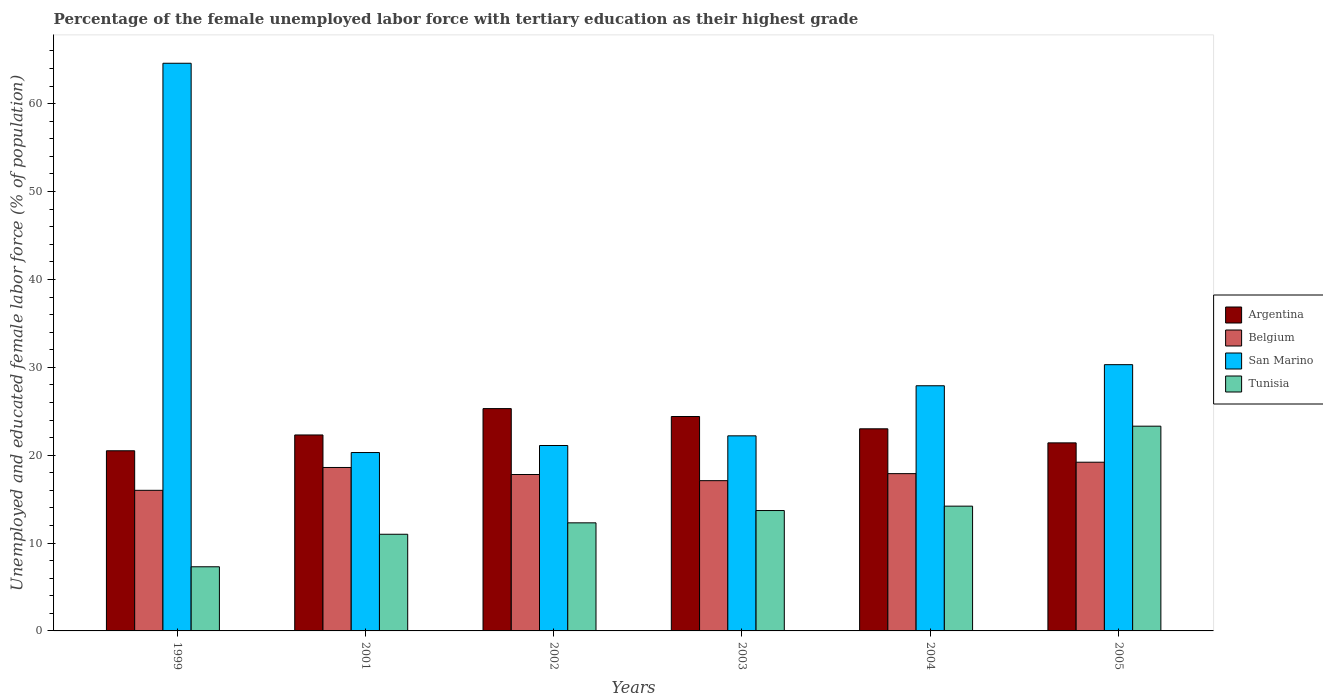Are the number of bars per tick equal to the number of legend labels?
Your answer should be very brief. Yes. Are the number of bars on each tick of the X-axis equal?
Make the answer very short. Yes. How many bars are there on the 2nd tick from the left?
Your response must be concise. 4. What is the label of the 2nd group of bars from the left?
Your response must be concise. 2001. In how many cases, is the number of bars for a given year not equal to the number of legend labels?
Keep it short and to the point. 0. What is the percentage of the unemployed female labor force with tertiary education in Belgium in 2001?
Keep it short and to the point. 18.6. Across all years, what is the maximum percentage of the unemployed female labor force with tertiary education in San Marino?
Your answer should be very brief. 64.6. Across all years, what is the minimum percentage of the unemployed female labor force with tertiary education in Argentina?
Give a very brief answer. 20.5. In which year was the percentage of the unemployed female labor force with tertiary education in Tunisia maximum?
Offer a terse response. 2005. In which year was the percentage of the unemployed female labor force with tertiary education in Belgium minimum?
Provide a short and direct response. 1999. What is the total percentage of the unemployed female labor force with tertiary education in Argentina in the graph?
Provide a succinct answer. 136.9. What is the difference between the percentage of the unemployed female labor force with tertiary education in San Marino in 1999 and that in 2005?
Provide a short and direct response. 34.3. What is the difference between the percentage of the unemployed female labor force with tertiary education in Tunisia in 2003 and the percentage of the unemployed female labor force with tertiary education in Belgium in 2005?
Your answer should be compact. -5.5. What is the average percentage of the unemployed female labor force with tertiary education in Argentina per year?
Your answer should be very brief. 22.82. In the year 2001, what is the difference between the percentage of the unemployed female labor force with tertiary education in San Marino and percentage of the unemployed female labor force with tertiary education in Belgium?
Ensure brevity in your answer.  1.7. In how many years, is the percentage of the unemployed female labor force with tertiary education in Belgium greater than 16 %?
Give a very brief answer. 5. What is the ratio of the percentage of the unemployed female labor force with tertiary education in Belgium in 2003 to that in 2004?
Keep it short and to the point. 0.96. What is the difference between the highest and the second highest percentage of the unemployed female labor force with tertiary education in Tunisia?
Your answer should be compact. 9.1. What is the difference between the highest and the lowest percentage of the unemployed female labor force with tertiary education in Belgium?
Your answer should be very brief. 3.2. What does the 3rd bar from the left in 2001 represents?
Offer a terse response. San Marino. What does the 3rd bar from the right in 2005 represents?
Provide a short and direct response. Belgium. Is it the case that in every year, the sum of the percentage of the unemployed female labor force with tertiary education in Argentina and percentage of the unemployed female labor force with tertiary education in Tunisia is greater than the percentage of the unemployed female labor force with tertiary education in San Marino?
Your answer should be very brief. No. How many bars are there?
Offer a very short reply. 24. Are all the bars in the graph horizontal?
Provide a short and direct response. No. How many years are there in the graph?
Offer a very short reply. 6. What is the difference between two consecutive major ticks on the Y-axis?
Your answer should be compact. 10. Are the values on the major ticks of Y-axis written in scientific E-notation?
Your answer should be compact. No. Does the graph contain any zero values?
Provide a short and direct response. No. What is the title of the graph?
Your response must be concise. Percentage of the female unemployed labor force with tertiary education as their highest grade. Does "Mali" appear as one of the legend labels in the graph?
Give a very brief answer. No. What is the label or title of the Y-axis?
Your answer should be very brief. Unemployed and educated female labor force (% of population). What is the Unemployed and educated female labor force (% of population) of Belgium in 1999?
Your answer should be compact. 16. What is the Unemployed and educated female labor force (% of population) in San Marino in 1999?
Make the answer very short. 64.6. What is the Unemployed and educated female labor force (% of population) of Tunisia in 1999?
Provide a succinct answer. 7.3. What is the Unemployed and educated female labor force (% of population) in Argentina in 2001?
Provide a succinct answer. 22.3. What is the Unemployed and educated female labor force (% of population) of Belgium in 2001?
Make the answer very short. 18.6. What is the Unemployed and educated female labor force (% of population) in San Marino in 2001?
Keep it short and to the point. 20.3. What is the Unemployed and educated female labor force (% of population) of Tunisia in 2001?
Provide a succinct answer. 11. What is the Unemployed and educated female labor force (% of population) in Argentina in 2002?
Ensure brevity in your answer.  25.3. What is the Unemployed and educated female labor force (% of population) in Belgium in 2002?
Offer a terse response. 17.8. What is the Unemployed and educated female labor force (% of population) of San Marino in 2002?
Your response must be concise. 21.1. What is the Unemployed and educated female labor force (% of population) of Tunisia in 2002?
Your response must be concise. 12.3. What is the Unemployed and educated female labor force (% of population) of Argentina in 2003?
Your response must be concise. 24.4. What is the Unemployed and educated female labor force (% of population) in Belgium in 2003?
Ensure brevity in your answer.  17.1. What is the Unemployed and educated female labor force (% of population) in San Marino in 2003?
Provide a short and direct response. 22.2. What is the Unemployed and educated female labor force (% of population) in Tunisia in 2003?
Offer a terse response. 13.7. What is the Unemployed and educated female labor force (% of population) of Belgium in 2004?
Offer a terse response. 17.9. What is the Unemployed and educated female labor force (% of population) of San Marino in 2004?
Ensure brevity in your answer.  27.9. What is the Unemployed and educated female labor force (% of population) in Tunisia in 2004?
Your answer should be very brief. 14.2. What is the Unemployed and educated female labor force (% of population) in Argentina in 2005?
Your response must be concise. 21.4. What is the Unemployed and educated female labor force (% of population) in Belgium in 2005?
Offer a very short reply. 19.2. What is the Unemployed and educated female labor force (% of population) in San Marino in 2005?
Your response must be concise. 30.3. What is the Unemployed and educated female labor force (% of population) in Tunisia in 2005?
Make the answer very short. 23.3. Across all years, what is the maximum Unemployed and educated female labor force (% of population) in Argentina?
Your answer should be compact. 25.3. Across all years, what is the maximum Unemployed and educated female labor force (% of population) of Belgium?
Provide a short and direct response. 19.2. Across all years, what is the maximum Unemployed and educated female labor force (% of population) in San Marino?
Offer a terse response. 64.6. Across all years, what is the maximum Unemployed and educated female labor force (% of population) of Tunisia?
Provide a succinct answer. 23.3. Across all years, what is the minimum Unemployed and educated female labor force (% of population) in San Marino?
Your answer should be very brief. 20.3. Across all years, what is the minimum Unemployed and educated female labor force (% of population) of Tunisia?
Keep it short and to the point. 7.3. What is the total Unemployed and educated female labor force (% of population) of Argentina in the graph?
Give a very brief answer. 136.9. What is the total Unemployed and educated female labor force (% of population) in Belgium in the graph?
Offer a very short reply. 106.6. What is the total Unemployed and educated female labor force (% of population) of San Marino in the graph?
Offer a very short reply. 186.4. What is the total Unemployed and educated female labor force (% of population) in Tunisia in the graph?
Offer a terse response. 81.8. What is the difference between the Unemployed and educated female labor force (% of population) in San Marino in 1999 and that in 2001?
Keep it short and to the point. 44.3. What is the difference between the Unemployed and educated female labor force (% of population) of Tunisia in 1999 and that in 2001?
Your response must be concise. -3.7. What is the difference between the Unemployed and educated female labor force (% of population) of Belgium in 1999 and that in 2002?
Provide a succinct answer. -1.8. What is the difference between the Unemployed and educated female labor force (% of population) of San Marino in 1999 and that in 2002?
Ensure brevity in your answer.  43.5. What is the difference between the Unemployed and educated female labor force (% of population) in Argentina in 1999 and that in 2003?
Provide a short and direct response. -3.9. What is the difference between the Unemployed and educated female labor force (% of population) of Belgium in 1999 and that in 2003?
Offer a terse response. -1.1. What is the difference between the Unemployed and educated female labor force (% of population) of San Marino in 1999 and that in 2003?
Provide a succinct answer. 42.4. What is the difference between the Unemployed and educated female labor force (% of population) in Tunisia in 1999 and that in 2003?
Provide a succinct answer. -6.4. What is the difference between the Unemployed and educated female labor force (% of population) of Argentina in 1999 and that in 2004?
Your answer should be compact. -2.5. What is the difference between the Unemployed and educated female labor force (% of population) of Belgium in 1999 and that in 2004?
Ensure brevity in your answer.  -1.9. What is the difference between the Unemployed and educated female labor force (% of population) of San Marino in 1999 and that in 2004?
Provide a short and direct response. 36.7. What is the difference between the Unemployed and educated female labor force (% of population) in San Marino in 1999 and that in 2005?
Your answer should be compact. 34.3. What is the difference between the Unemployed and educated female labor force (% of population) in Argentina in 2001 and that in 2002?
Your answer should be compact. -3. What is the difference between the Unemployed and educated female labor force (% of population) in Belgium in 2001 and that in 2002?
Provide a succinct answer. 0.8. What is the difference between the Unemployed and educated female labor force (% of population) of Tunisia in 2001 and that in 2002?
Keep it short and to the point. -1.3. What is the difference between the Unemployed and educated female labor force (% of population) in Argentina in 2001 and that in 2003?
Offer a terse response. -2.1. What is the difference between the Unemployed and educated female labor force (% of population) of Belgium in 2001 and that in 2004?
Provide a short and direct response. 0.7. What is the difference between the Unemployed and educated female labor force (% of population) in Tunisia in 2001 and that in 2004?
Ensure brevity in your answer.  -3.2. What is the difference between the Unemployed and educated female labor force (% of population) of San Marino in 2001 and that in 2005?
Offer a very short reply. -10. What is the difference between the Unemployed and educated female labor force (% of population) of Argentina in 2002 and that in 2003?
Offer a terse response. 0.9. What is the difference between the Unemployed and educated female labor force (% of population) of Belgium in 2002 and that in 2003?
Make the answer very short. 0.7. What is the difference between the Unemployed and educated female labor force (% of population) of San Marino in 2002 and that in 2003?
Keep it short and to the point. -1.1. What is the difference between the Unemployed and educated female labor force (% of population) of Belgium in 2002 and that in 2004?
Offer a very short reply. -0.1. What is the difference between the Unemployed and educated female labor force (% of population) of San Marino in 2002 and that in 2004?
Make the answer very short. -6.8. What is the difference between the Unemployed and educated female labor force (% of population) in Tunisia in 2002 and that in 2004?
Make the answer very short. -1.9. What is the difference between the Unemployed and educated female labor force (% of population) of San Marino in 2002 and that in 2005?
Provide a short and direct response. -9.2. What is the difference between the Unemployed and educated female labor force (% of population) of Tunisia in 2002 and that in 2005?
Provide a short and direct response. -11. What is the difference between the Unemployed and educated female labor force (% of population) of Belgium in 2003 and that in 2004?
Make the answer very short. -0.8. What is the difference between the Unemployed and educated female labor force (% of population) of San Marino in 2003 and that in 2004?
Ensure brevity in your answer.  -5.7. What is the difference between the Unemployed and educated female labor force (% of population) of Argentina in 2003 and that in 2005?
Provide a short and direct response. 3. What is the difference between the Unemployed and educated female labor force (% of population) in Belgium in 2003 and that in 2005?
Offer a terse response. -2.1. What is the difference between the Unemployed and educated female labor force (% of population) of San Marino in 2004 and that in 2005?
Provide a succinct answer. -2.4. What is the difference between the Unemployed and educated female labor force (% of population) in Argentina in 1999 and the Unemployed and educated female labor force (% of population) in San Marino in 2001?
Offer a very short reply. 0.2. What is the difference between the Unemployed and educated female labor force (% of population) in Argentina in 1999 and the Unemployed and educated female labor force (% of population) in Tunisia in 2001?
Provide a succinct answer. 9.5. What is the difference between the Unemployed and educated female labor force (% of population) of Belgium in 1999 and the Unemployed and educated female labor force (% of population) of San Marino in 2001?
Provide a short and direct response. -4.3. What is the difference between the Unemployed and educated female labor force (% of population) in San Marino in 1999 and the Unemployed and educated female labor force (% of population) in Tunisia in 2001?
Offer a very short reply. 53.6. What is the difference between the Unemployed and educated female labor force (% of population) in Argentina in 1999 and the Unemployed and educated female labor force (% of population) in Belgium in 2002?
Provide a succinct answer. 2.7. What is the difference between the Unemployed and educated female labor force (% of population) in Argentina in 1999 and the Unemployed and educated female labor force (% of population) in San Marino in 2002?
Offer a terse response. -0.6. What is the difference between the Unemployed and educated female labor force (% of population) of Argentina in 1999 and the Unemployed and educated female labor force (% of population) of Tunisia in 2002?
Your answer should be very brief. 8.2. What is the difference between the Unemployed and educated female labor force (% of population) of Belgium in 1999 and the Unemployed and educated female labor force (% of population) of San Marino in 2002?
Provide a succinct answer. -5.1. What is the difference between the Unemployed and educated female labor force (% of population) of Belgium in 1999 and the Unemployed and educated female labor force (% of population) of Tunisia in 2002?
Make the answer very short. 3.7. What is the difference between the Unemployed and educated female labor force (% of population) of San Marino in 1999 and the Unemployed and educated female labor force (% of population) of Tunisia in 2002?
Your answer should be compact. 52.3. What is the difference between the Unemployed and educated female labor force (% of population) of Argentina in 1999 and the Unemployed and educated female labor force (% of population) of Tunisia in 2003?
Offer a very short reply. 6.8. What is the difference between the Unemployed and educated female labor force (% of population) of Belgium in 1999 and the Unemployed and educated female labor force (% of population) of Tunisia in 2003?
Keep it short and to the point. 2.3. What is the difference between the Unemployed and educated female labor force (% of population) in San Marino in 1999 and the Unemployed and educated female labor force (% of population) in Tunisia in 2003?
Ensure brevity in your answer.  50.9. What is the difference between the Unemployed and educated female labor force (% of population) in Argentina in 1999 and the Unemployed and educated female labor force (% of population) in San Marino in 2004?
Provide a short and direct response. -7.4. What is the difference between the Unemployed and educated female labor force (% of population) of San Marino in 1999 and the Unemployed and educated female labor force (% of population) of Tunisia in 2004?
Ensure brevity in your answer.  50.4. What is the difference between the Unemployed and educated female labor force (% of population) of Argentina in 1999 and the Unemployed and educated female labor force (% of population) of Belgium in 2005?
Keep it short and to the point. 1.3. What is the difference between the Unemployed and educated female labor force (% of population) in Argentina in 1999 and the Unemployed and educated female labor force (% of population) in San Marino in 2005?
Your response must be concise. -9.8. What is the difference between the Unemployed and educated female labor force (% of population) in Belgium in 1999 and the Unemployed and educated female labor force (% of population) in San Marino in 2005?
Your answer should be compact. -14.3. What is the difference between the Unemployed and educated female labor force (% of population) in Belgium in 1999 and the Unemployed and educated female labor force (% of population) in Tunisia in 2005?
Your answer should be very brief. -7.3. What is the difference between the Unemployed and educated female labor force (% of population) of San Marino in 1999 and the Unemployed and educated female labor force (% of population) of Tunisia in 2005?
Provide a short and direct response. 41.3. What is the difference between the Unemployed and educated female labor force (% of population) of Argentina in 2001 and the Unemployed and educated female labor force (% of population) of San Marino in 2002?
Provide a short and direct response. 1.2. What is the difference between the Unemployed and educated female labor force (% of population) in Belgium in 2001 and the Unemployed and educated female labor force (% of population) in San Marino in 2002?
Your answer should be compact. -2.5. What is the difference between the Unemployed and educated female labor force (% of population) in Argentina in 2001 and the Unemployed and educated female labor force (% of population) in Belgium in 2003?
Keep it short and to the point. 5.2. What is the difference between the Unemployed and educated female labor force (% of population) of Argentina in 2001 and the Unemployed and educated female labor force (% of population) of San Marino in 2003?
Your answer should be very brief. 0.1. What is the difference between the Unemployed and educated female labor force (% of population) of Argentina in 2001 and the Unemployed and educated female labor force (% of population) of Tunisia in 2003?
Your response must be concise. 8.6. What is the difference between the Unemployed and educated female labor force (% of population) of San Marino in 2001 and the Unemployed and educated female labor force (% of population) of Tunisia in 2003?
Offer a very short reply. 6.6. What is the difference between the Unemployed and educated female labor force (% of population) in Argentina in 2001 and the Unemployed and educated female labor force (% of population) in San Marino in 2004?
Give a very brief answer. -5.6. What is the difference between the Unemployed and educated female labor force (% of population) of Argentina in 2001 and the Unemployed and educated female labor force (% of population) of Tunisia in 2004?
Your answer should be very brief. 8.1. What is the difference between the Unemployed and educated female labor force (% of population) of Belgium in 2001 and the Unemployed and educated female labor force (% of population) of Tunisia in 2004?
Your answer should be very brief. 4.4. What is the difference between the Unemployed and educated female labor force (% of population) in San Marino in 2001 and the Unemployed and educated female labor force (% of population) in Tunisia in 2004?
Ensure brevity in your answer.  6.1. What is the difference between the Unemployed and educated female labor force (% of population) of Belgium in 2001 and the Unemployed and educated female labor force (% of population) of San Marino in 2005?
Ensure brevity in your answer.  -11.7. What is the difference between the Unemployed and educated female labor force (% of population) of Belgium in 2001 and the Unemployed and educated female labor force (% of population) of Tunisia in 2005?
Your answer should be compact. -4.7. What is the difference between the Unemployed and educated female labor force (% of population) in Argentina in 2002 and the Unemployed and educated female labor force (% of population) in Belgium in 2003?
Offer a terse response. 8.2. What is the difference between the Unemployed and educated female labor force (% of population) of Argentina in 2002 and the Unemployed and educated female labor force (% of population) of Tunisia in 2003?
Provide a succinct answer. 11.6. What is the difference between the Unemployed and educated female labor force (% of population) in San Marino in 2002 and the Unemployed and educated female labor force (% of population) in Tunisia in 2003?
Your answer should be very brief. 7.4. What is the difference between the Unemployed and educated female labor force (% of population) of Argentina in 2002 and the Unemployed and educated female labor force (% of population) of Belgium in 2004?
Your answer should be very brief. 7.4. What is the difference between the Unemployed and educated female labor force (% of population) of Argentina in 2002 and the Unemployed and educated female labor force (% of population) of Tunisia in 2004?
Your answer should be very brief. 11.1. What is the difference between the Unemployed and educated female labor force (% of population) of Belgium in 2002 and the Unemployed and educated female labor force (% of population) of Tunisia in 2004?
Ensure brevity in your answer.  3.6. What is the difference between the Unemployed and educated female labor force (% of population) of San Marino in 2002 and the Unemployed and educated female labor force (% of population) of Tunisia in 2004?
Keep it short and to the point. 6.9. What is the difference between the Unemployed and educated female labor force (% of population) in Argentina in 2002 and the Unemployed and educated female labor force (% of population) in Belgium in 2005?
Your answer should be very brief. 6.1. What is the difference between the Unemployed and educated female labor force (% of population) in Argentina in 2002 and the Unemployed and educated female labor force (% of population) in Tunisia in 2005?
Give a very brief answer. 2. What is the difference between the Unemployed and educated female labor force (% of population) of Belgium in 2002 and the Unemployed and educated female labor force (% of population) of Tunisia in 2005?
Your response must be concise. -5.5. What is the difference between the Unemployed and educated female labor force (% of population) in San Marino in 2002 and the Unemployed and educated female labor force (% of population) in Tunisia in 2005?
Give a very brief answer. -2.2. What is the difference between the Unemployed and educated female labor force (% of population) of Argentina in 2003 and the Unemployed and educated female labor force (% of population) of San Marino in 2004?
Keep it short and to the point. -3.5. What is the difference between the Unemployed and educated female labor force (% of population) of Argentina in 2003 and the Unemployed and educated female labor force (% of population) of Tunisia in 2004?
Provide a succinct answer. 10.2. What is the difference between the Unemployed and educated female labor force (% of population) of Belgium in 2003 and the Unemployed and educated female labor force (% of population) of San Marino in 2004?
Your answer should be compact. -10.8. What is the difference between the Unemployed and educated female labor force (% of population) in Argentina in 2003 and the Unemployed and educated female labor force (% of population) in Belgium in 2005?
Provide a short and direct response. 5.2. What is the difference between the Unemployed and educated female labor force (% of population) in Belgium in 2003 and the Unemployed and educated female labor force (% of population) in Tunisia in 2005?
Provide a short and direct response. -6.2. What is the difference between the Unemployed and educated female labor force (% of population) in San Marino in 2003 and the Unemployed and educated female labor force (% of population) in Tunisia in 2005?
Keep it short and to the point. -1.1. What is the difference between the Unemployed and educated female labor force (% of population) of Argentina in 2004 and the Unemployed and educated female labor force (% of population) of Tunisia in 2005?
Offer a terse response. -0.3. What is the difference between the Unemployed and educated female labor force (% of population) in Belgium in 2004 and the Unemployed and educated female labor force (% of population) in San Marino in 2005?
Make the answer very short. -12.4. What is the difference between the Unemployed and educated female labor force (% of population) in San Marino in 2004 and the Unemployed and educated female labor force (% of population) in Tunisia in 2005?
Keep it short and to the point. 4.6. What is the average Unemployed and educated female labor force (% of population) of Argentina per year?
Your response must be concise. 22.82. What is the average Unemployed and educated female labor force (% of population) of Belgium per year?
Your answer should be compact. 17.77. What is the average Unemployed and educated female labor force (% of population) in San Marino per year?
Offer a very short reply. 31.07. What is the average Unemployed and educated female labor force (% of population) in Tunisia per year?
Ensure brevity in your answer.  13.63. In the year 1999, what is the difference between the Unemployed and educated female labor force (% of population) of Argentina and Unemployed and educated female labor force (% of population) of Belgium?
Provide a short and direct response. 4.5. In the year 1999, what is the difference between the Unemployed and educated female labor force (% of population) in Argentina and Unemployed and educated female labor force (% of population) in San Marino?
Keep it short and to the point. -44.1. In the year 1999, what is the difference between the Unemployed and educated female labor force (% of population) in Argentina and Unemployed and educated female labor force (% of population) in Tunisia?
Make the answer very short. 13.2. In the year 1999, what is the difference between the Unemployed and educated female labor force (% of population) of Belgium and Unemployed and educated female labor force (% of population) of San Marino?
Provide a short and direct response. -48.6. In the year 1999, what is the difference between the Unemployed and educated female labor force (% of population) of Belgium and Unemployed and educated female labor force (% of population) of Tunisia?
Provide a succinct answer. 8.7. In the year 1999, what is the difference between the Unemployed and educated female labor force (% of population) in San Marino and Unemployed and educated female labor force (% of population) in Tunisia?
Keep it short and to the point. 57.3. In the year 2001, what is the difference between the Unemployed and educated female labor force (% of population) in Argentina and Unemployed and educated female labor force (% of population) in Belgium?
Offer a very short reply. 3.7. In the year 2001, what is the difference between the Unemployed and educated female labor force (% of population) in Argentina and Unemployed and educated female labor force (% of population) in San Marino?
Make the answer very short. 2. In the year 2001, what is the difference between the Unemployed and educated female labor force (% of population) of Argentina and Unemployed and educated female labor force (% of population) of Tunisia?
Keep it short and to the point. 11.3. In the year 2001, what is the difference between the Unemployed and educated female labor force (% of population) in Belgium and Unemployed and educated female labor force (% of population) in San Marino?
Make the answer very short. -1.7. In the year 2001, what is the difference between the Unemployed and educated female labor force (% of population) of San Marino and Unemployed and educated female labor force (% of population) of Tunisia?
Provide a succinct answer. 9.3. In the year 2002, what is the difference between the Unemployed and educated female labor force (% of population) of Argentina and Unemployed and educated female labor force (% of population) of Belgium?
Your answer should be very brief. 7.5. In the year 2002, what is the difference between the Unemployed and educated female labor force (% of population) in Argentina and Unemployed and educated female labor force (% of population) in San Marino?
Offer a terse response. 4.2. In the year 2002, what is the difference between the Unemployed and educated female labor force (% of population) in Argentina and Unemployed and educated female labor force (% of population) in Tunisia?
Your answer should be very brief. 13. In the year 2002, what is the difference between the Unemployed and educated female labor force (% of population) of San Marino and Unemployed and educated female labor force (% of population) of Tunisia?
Provide a short and direct response. 8.8. In the year 2003, what is the difference between the Unemployed and educated female labor force (% of population) of Argentina and Unemployed and educated female labor force (% of population) of Tunisia?
Keep it short and to the point. 10.7. In the year 2003, what is the difference between the Unemployed and educated female labor force (% of population) of Belgium and Unemployed and educated female labor force (% of population) of San Marino?
Offer a terse response. -5.1. In the year 2003, what is the difference between the Unemployed and educated female labor force (% of population) in Belgium and Unemployed and educated female labor force (% of population) in Tunisia?
Ensure brevity in your answer.  3.4. In the year 2003, what is the difference between the Unemployed and educated female labor force (% of population) in San Marino and Unemployed and educated female labor force (% of population) in Tunisia?
Give a very brief answer. 8.5. In the year 2004, what is the difference between the Unemployed and educated female labor force (% of population) of Argentina and Unemployed and educated female labor force (% of population) of Belgium?
Provide a succinct answer. 5.1. In the year 2004, what is the difference between the Unemployed and educated female labor force (% of population) in Belgium and Unemployed and educated female labor force (% of population) in Tunisia?
Your answer should be very brief. 3.7. In the year 2005, what is the difference between the Unemployed and educated female labor force (% of population) of Argentina and Unemployed and educated female labor force (% of population) of Belgium?
Keep it short and to the point. 2.2. In the year 2005, what is the difference between the Unemployed and educated female labor force (% of population) of Argentina and Unemployed and educated female labor force (% of population) of San Marino?
Give a very brief answer. -8.9. In the year 2005, what is the difference between the Unemployed and educated female labor force (% of population) in Belgium and Unemployed and educated female labor force (% of population) in San Marino?
Your answer should be compact. -11.1. In the year 2005, what is the difference between the Unemployed and educated female labor force (% of population) in Belgium and Unemployed and educated female labor force (% of population) in Tunisia?
Ensure brevity in your answer.  -4.1. In the year 2005, what is the difference between the Unemployed and educated female labor force (% of population) of San Marino and Unemployed and educated female labor force (% of population) of Tunisia?
Your answer should be compact. 7. What is the ratio of the Unemployed and educated female labor force (% of population) in Argentina in 1999 to that in 2001?
Give a very brief answer. 0.92. What is the ratio of the Unemployed and educated female labor force (% of population) of Belgium in 1999 to that in 2001?
Your response must be concise. 0.86. What is the ratio of the Unemployed and educated female labor force (% of population) of San Marino in 1999 to that in 2001?
Keep it short and to the point. 3.18. What is the ratio of the Unemployed and educated female labor force (% of population) of Tunisia in 1999 to that in 2001?
Ensure brevity in your answer.  0.66. What is the ratio of the Unemployed and educated female labor force (% of population) in Argentina in 1999 to that in 2002?
Make the answer very short. 0.81. What is the ratio of the Unemployed and educated female labor force (% of population) in Belgium in 1999 to that in 2002?
Give a very brief answer. 0.9. What is the ratio of the Unemployed and educated female labor force (% of population) of San Marino in 1999 to that in 2002?
Keep it short and to the point. 3.06. What is the ratio of the Unemployed and educated female labor force (% of population) in Tunisia in 1999 to that in 2002?
Your response must be concise. 0.59. What is the ratio of the Unemployed and educated female labor force (% of population) of Argentina in 1999 to that in 2003?
Make the answer very short. 0.84. What is the ratio of the Unemployed and educated female labor force (% of population) of Belgium in 1999 to that in 2003?
Keep it short and to the point. 0.94. What is the ratio of the Unemployed and educated female labor force (% of population) in San Marino in 1999 to that in 2003?
Make the answer very short. 2.91. What is the ratio of the Unemployed and educated female labor force (% of population) of Tunisia in 1999 to that in 2003?
Offer a terse response. 0.53. What is the ratio of the Unemployed and educated female labor force (% of population) in Argentina in 1999 to that in 2004?
Give a very brief answer. 0.89. What is the ratio of the Unemployed and educated female labor force (% of population) in Belgium in 1999 to that in 2004?
Provide a short and direct response. 0.89. What is the ratio of the Unemployed and educated female labor force (% of population) of San Marino in 1999 to that in 2004?
Your response must be concise. 2.32. What is the ratio of the Unemployed and educated female labor force (% of population) of Tunisia in 1999 to that in 2004?
Your answer should be very brief. 0.51. What is the ratio of the Unemployed and educated female labor force (% of population) in Argentina in 1999 to that in 2005?
Your answer should be compact. 0.96. What is the ratio of the Unemployed and educated female labor force (% of population) of Belgium in 1999 to that in 2005?
Your answer should be compact. 0.83. What is the ratio of the Unemployed and educated female labor force (% of population) of San Marino in 1999 to that in 2005?
Your response must be concise. 2.13. What is the ratio of the Unemployed and educated female labor force (% of population) in Tunisia in 1999 to that in 2005?
Keep it short and to the point. 0.31. What is the ratio of the Unemployed and educated female labor force (% of population) in Argentina in 2001 to that in 2002?
Provide a succinct answer. 0.88. What is the ratio of the Unemployed and educated female labor force (% of population) in Belgium in 2001 to that in 2002?
Your answer should be compact. 1.04. What is the ratio of the Unemployed and educated female labor force (% of population) in San Marino in 2001 to that in 2002?
Keep it short and to the point. 0.96. What is the ratio of the Unemployed and educated female labor force (% of population) of Tunisia in 2001 to that in 2002?
Make the answer very short. 0.89. What is the ratio of the Unemployed and educated female labor force (% of population) of Argentina in 2001 to that in 2003?
Ensure brevity in your answer.  0.91. What is the ratio of the Unemployed and educated female labor force (% of population) of Belgium in 2001 to that in 2003?
Give a very brief answer. 1.09. What is the ratio of the Unemployed and educated female labor force (% of population) of San Marino in 2001 to that in 2003?
Your response must be concise. 0.91. What is the ratio of the Unemployed and educated female labor force (% of population) in Tunisia in 2001 to that in 2003?
Your answer should be very brief. 0.8. What is the ratio of the Unemployed and educated female labor force (% of population) in Argentina in 2001 to that in 2004?
Keep it short and to the point. 0.97. What is the ratio of the Unemployed and educated female labor force (% of population) of Belgium in 2001 to that in 2004?
Keep it short and to the point. 1.04. What is the ratio of the Unemployed and educated female labor force (% of population) of San Marino in 2001 to that in 2004?
Your answer should be very brief. 0.73. What is the ratio of the Unemployed and educated female labor force (% of population) of Tunisia in 2001 to that in 2004?
Your answer should be very brief. 0.77. What is the ratio of the Unemployed and educated female labor force (% of population) in Argentina in 2001 to that in 2005?
Make the answer very short. 1.04. What is the ratio of the Unemployed and educated female labor force (% of population) in Belgium in 2001 to that in 2005?
Give a very brief answer. 0.97. What is the ratio of the Unemployed and educated female labor force (% of population) of San Marino in 2001 to that in 2005?
Give a very brief answer. 0.67. What is the ratio of the Unemployed and educated female labor force (% of population) in Tunisia in 2001 to that in 2005?
Ensure brevity in your answer.  0.47. What is the ratio of the Unemployed and educated female labor force (% of population) in Argentina in 2002 to that in 2003?
Your response must be concise. 1.04. What is the ratio of the Unemployed and educated female labor force (% of population) in Belgium in 2002 to that in 2003?
Ensure brevity in your answer.  1.04. What is the ratio of the Unemployed and educated female labor force (% of population) in San Marino in 2002 to that in 2003?
Your answer should be compact. 0.95. What is the ratio of the Unemployed and educated female labor force (% of population) of Tunisia in 2002 to that in 2003?
Your answer should be compact. 0.9. What is the ratio of the Unemployed and educated female labor force (% of population) in Argentina in 2002 to that in 2004?
Provide a short and direct response. 1.1. What is the ratio of the Unemployed and educated female labor force (% of population) of San Marino in 2002 to that in 2004?
Make the answer very short. 0.76. What is the ratio of the Unemployed and educated female labor force (% of population) in Tunisia in 2002 to that in 2004?
Your response must be concise. 0.87. What is the ratio of the Unemployed and educated female labor force (% of population) in Argentina in 2002 to that in 2005?
Offer a very short reply. 1.18. What is the ratio of the Unemployed and educated female labor force (% of population) in Belgium in 2002 to that in 2005?
Provide a succinct answer. 0.93. What is the ratio of the Unemployed and educated female labor force (% of population) in San Marino in 2002 to that in 2005?
Your response must be concise. 0.7. What is the ratio of the Unemployed and educated female labor force (% of population) of Tunisia in 2002 to that in 2005?
Your answer should be compact. 0.53. What is the ratio of the Unemployed and educated female labor force (% of population) in Argentina in 2003 to that in 2004?
Make the answer very short. 1.06. What is the ratio of the Unemployed and educated female labor force (% of population) in Belgium in 2003 to that in 2004?
Your response must be concise. 0.96. What is the ratio of the Unemployed and educated female labor force (% of population) in San Marino in 2003 to that in 2004?
Your response must be concise. 0.8. What is the ratio of the Unemployed and educated female labor force (% of population) of Tunisia in 2003 to that in 2004?
Your answer should be very brief. 0.96. What is the ratio of the Unemployed and educated female labor force (% of population) in Argentina in 2003 to that in 2005?
Your answer should be compact. 1.14. What is the ratio of the Unemployed and educated female labor force (% of population) of Belgium in 2003 to that in 2005?
Provide a succinct answer. 0.89. What is the ratio of the Unemployed and educated female labor force (% of population) in San Marino in 2003 to that in 2005?
Your answer should be compact. 0.73. What is the ratio of the Unemployed and educated female labor force (% of population) in Tunisia in 2003 to that in 2005?
Ensure brevity in your answer.  0.59. What is the ratio of the Unemployed and educated female labor force (% of population) of Argentina in 2004 to that in 2005?
Offer a very short reply. 1.07. What is the ratio of the Unemployed and educated female labor force (% of population) in Belgium in 2004 to that in 2005?
Offer a terse response. 0.93. What is the ratio of the Unemployed and educated female labor force (% of population) of San Marino in 2004 to that in 2005?
Offer a terse response. 0.92. What is the ratio of the Unemployed and educated female labor force (% of population) of Tunisia in 2004 to that in 2005?
Offer a very short reply. 0.61. What is the difference between the highest and the second highest Unemployed and educated female labor force (% of population) in San Marino?
Offer a very short reply. 34.3. What is the difference between the highest and the second highest Unemployed and educated female labor force (% of population) of Tunisia?
Give a very brief answer. 9.1. What is the difference between the highest and the lowest Unemployed and educated female labor force (% of population) of Argentina?
Ensure brevity in your answer.  4.8. What is the difference between the highest and the lowest Unemployed and educated female labor force (% of population) in San Marino?
Provide a succinct answer. 44.3. What is the difference between the highest and the lowest Unemployed and educated female labor force (% of population) of Tunisia?
Ensure brevity in your answer.  16. 